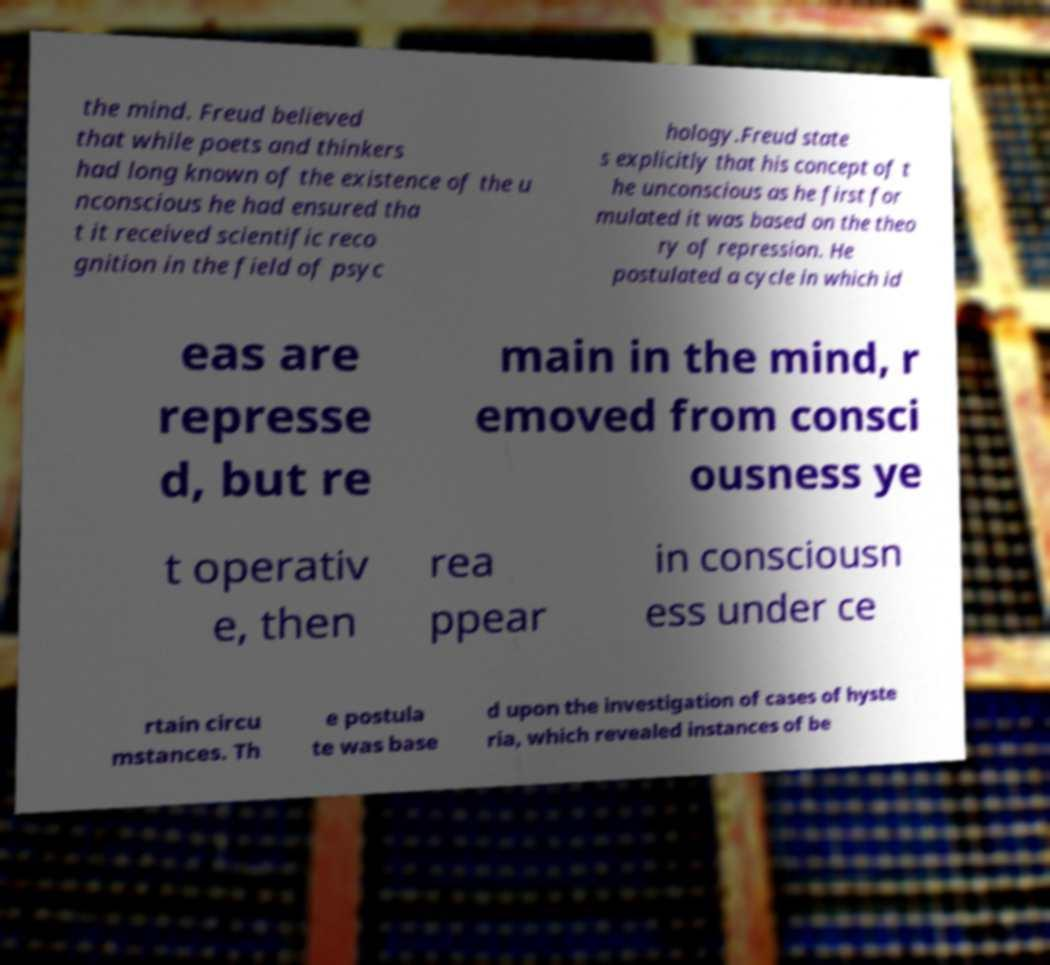Could you extract and type out the text from this image? the mind. Freud believed that while poets and thinkers had long known of the existence of the u nconscious he had ensured tha t it received scientific reco gnition in the field of psyc hology.Freud state s explicitly that his concept of t he unconscious as he first for mulated it was based on the theo ry of repression. He postulated a cycle in which id eas are represse d, but re main in the mind, r emoved from consci ousness ye t operativ e, then rea ppear in consciousn ess under ce rtain circu mstances. Th e postula te was base d upon the investigation of cases of hyste ria, which revealed instances of be 